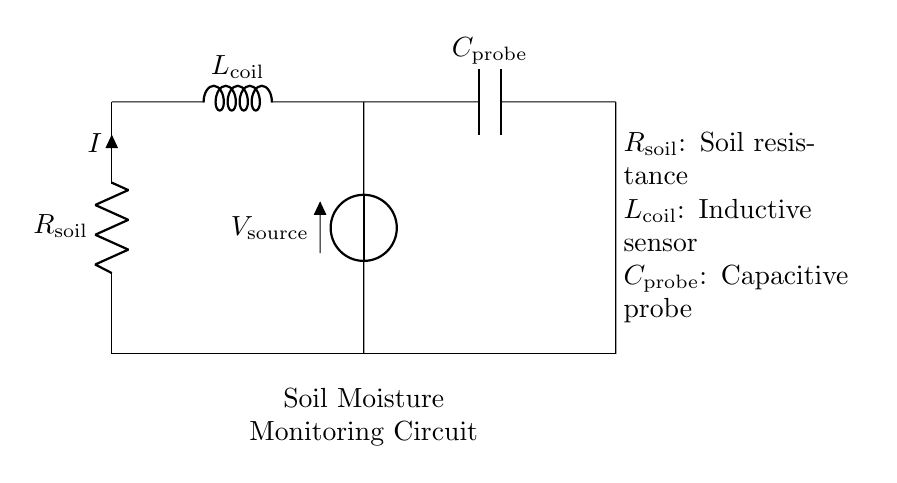What is the resistance in the circuit? The resistance in this circuit is denoted as R_soil, which is the label for the resistor connected in series with the rest of the components.
Answer: R_soil What component represents the inductive sensor? The inductive sensor in the circuit is represented by the component L_coil, which stands for the inductor shown in the circuit diagram.
Answer: L_coil What does the capacitive probe measure? The capacitive probe, labeled as C_probe, measures the soil moisture levels by detecting changes in capacitance due to water content in the soil.
Answer: Soil moisture What is the voltage source in the circuit? The voltage source is indicated as V_source, which supplies electrical energy to the circuit, establishing the potential difference needed for current flow.
Answer: V_source How are the components connected? The components in the circuit are connected in a series configuration, forming a closed loop that allows current to flow through R_soil, L_coil, and C_probe sequentially.
Answer: In series What is the role of L_coil in this circuit? The role of L_coil (the inductor) in the circuit is to react to changes in current, which can help in monitoring soil moisture by influencing how the circuit responds to varying conditions in the soil.
Answer: Inductance What type of circuit is this? This is an RLC circuit, characterized by the combination of a resistor, inductor, and capacitor, which can be used for applications like soil moisture monitoring.
Answer: RLC circuit 